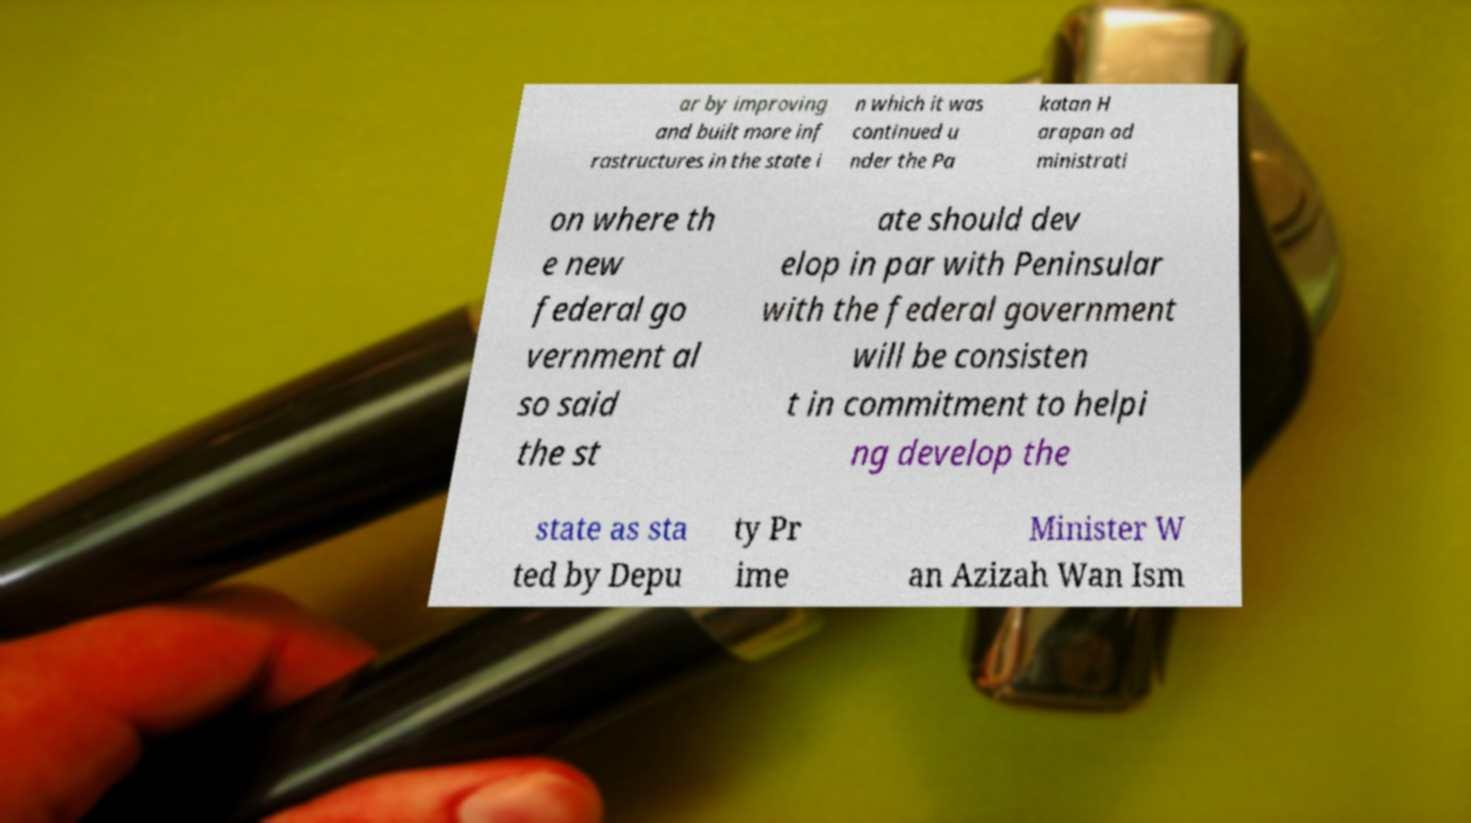I need the written content from this picture converted into text. Can you do that? ar by improving and built more inf rastructures in the state i n which it was continued u nder the Pa katan H arapan ad ministrati on where th e new federal go vernment al so said the st ate should dev elop in par with Peninsular with the federal government will be consisten t in commitment to helpi ng develop the state as sta ted by Depu ty Pr ime Minister W an Azizah Wan Ism 